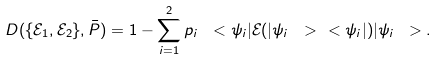<formula> <loc_0><loc_0><loc_500><loc_500>D ( \{ \mathcal { E } _ { 1 } , \mathcal { E } _ { 2 } \} , \bar { P } ) = 1 - \sum _ { i = 1 } ^ { 2 } p _ { i } \ < \psi _ { i } | \mathcal { E } ( | \psi _ { i } \ > \ < \psi _ { i } | ) | \psi _ { i } \ > .</formula> 